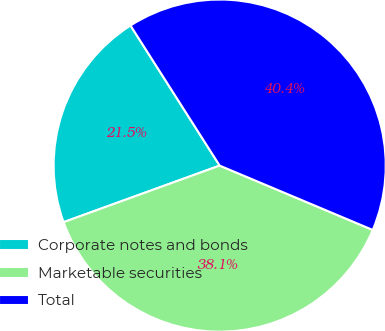Convert chart to OTSL. <chart><loc_0><loc_0><loc_500><loc_500><pie_chart><fcel>Corporate notes and bonds<fcel>Marketable securities<fcel>Total<nl><fcel>21.51%<fcel>38.13%<fcel>40.35%<nl></chart> 